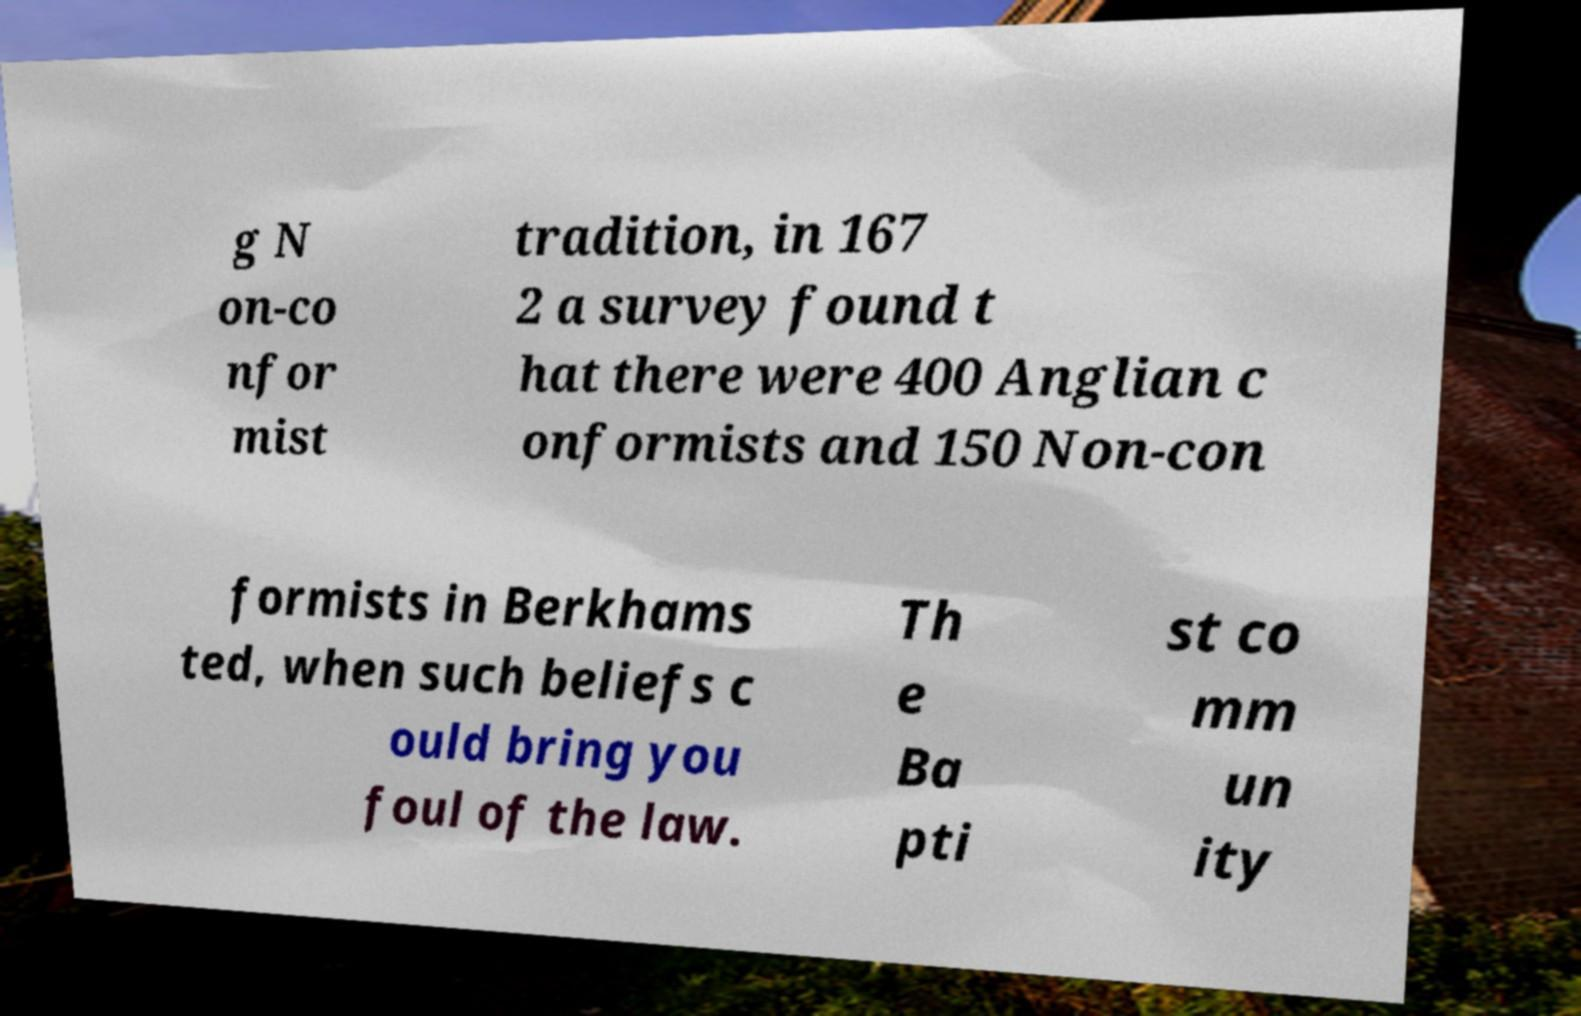There's text embedded in this image that I need extracted. Can you transcribe it verbatim? g N on-co nfor mist tradition, in 167 2 a survey found t hat there were 400 Anglian c onformists and 150 Non-con formists in Berkhams ted, when such beliefs c ould bring you foul of the law. Th e Ba pti st co mm un ity 